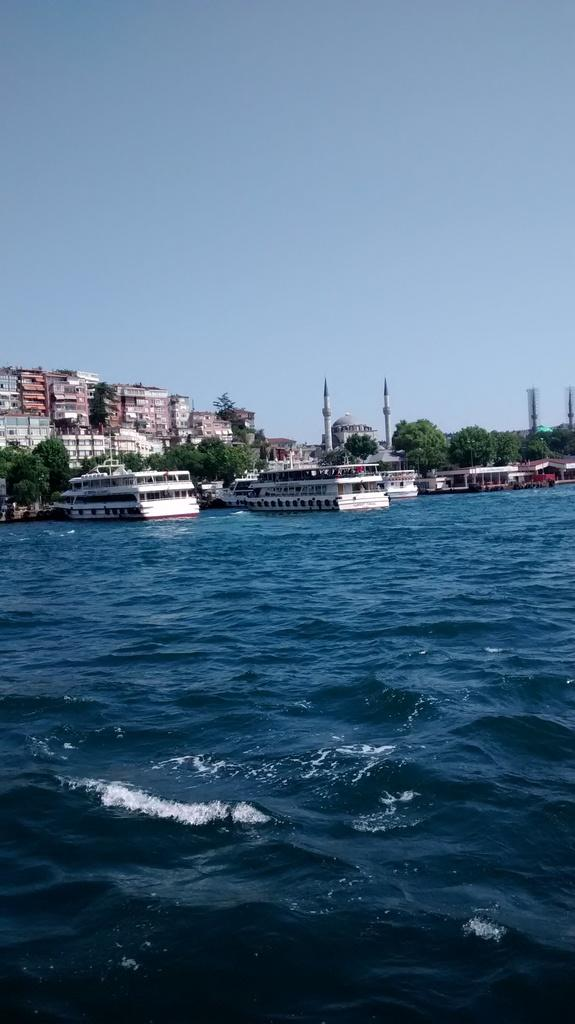What is the main feature of the image? The main feature of the image is water. What else can be seen in the water? There are boats in the water. What other elements are present in the image? There are trees and buildings in the image. What is visible at the top of the image? The sky is visible at the top of the image. What type of knife is being used to cut the ray in the image? There is no knife, ray, or any cutting activity present in the image. 